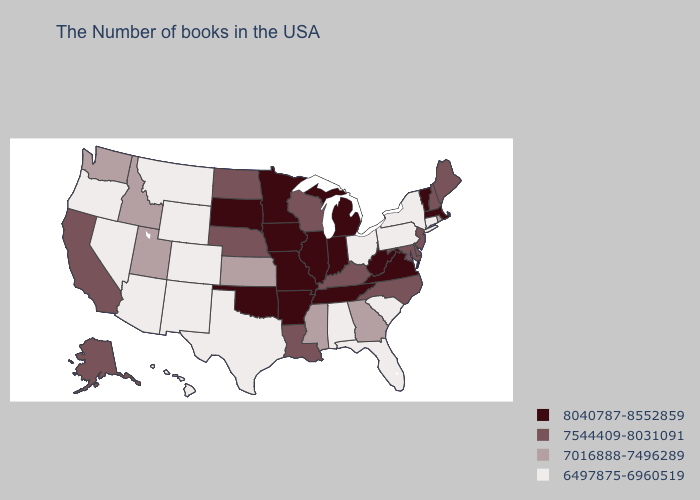What is the value of Florida?
Answer briefly. 6497875-6960519. Does South Carolina have the lowest value in the USA?
Short answer required. Yes. Does Indiana have a lower value than Wisconsin?
Keep it brief. No. Name the states that have a value in the range 7016888-7496289?
Give a very brief answer. Rhode Island, Georgia, Mississippi, Kansas, Utah, Idaho, Washington. What is the value of North Carolina?
Concise answer only. 7544409-8031091. Does the map have missing data?
Give a very brief answer. No. What is the value of North Dakota?
Give a very brief answer. 7544409-8031091. Name the states that have a value in the range 8040787-8552859?
Keep it brief. Massachusetts, Vermont, Virginia, West Virginia, Michigan, Indiana, Tennessee, Illinois, Missouri, Arkansas, Minnesota, Iowa, Oklahoma, South Dakota. Does Washington have the lowest value in the West?
Short answer required. No. Does West Virginia have the lowest value in the USA?
Concise answer only. No. What is the lowest value in the West?
Concise answer only. 6497875-6960519. Does the map have missing data?
Short answer required. No. Which states have the highest value in the USA?
Write a very short answer. Massachusetts, Vermont, Virginia, West Virginia, Michigan, Indiana, Tennessee, Illinois, Missouri, Arkansas, Minnesota, Iowa, Oklahoma, South Dakota. What is the value of West Virginia?
Be succinct. 8040787-8552859. 